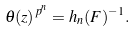<formula> <loc_0><loc_0><loc_500><loc_500>\theta ( z ) ^ { p ^ { n } } = h _ { n } ( F ) ^ { - 1 } .</formula> 